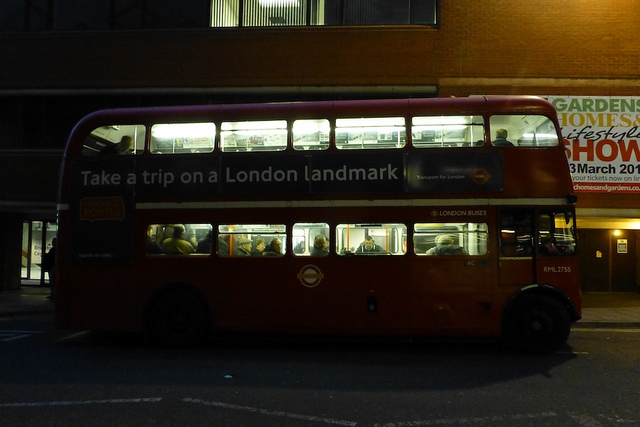Why is the light on inside the double-decker bus? The lights inside the double-decker bus are likely on for visibility and safety reasons, allowing passengers to see inside the bus during evening or nighttime hours. This helps people to move safely onboard, read or locate their belongings, and also signals to others that the bus is in service. 